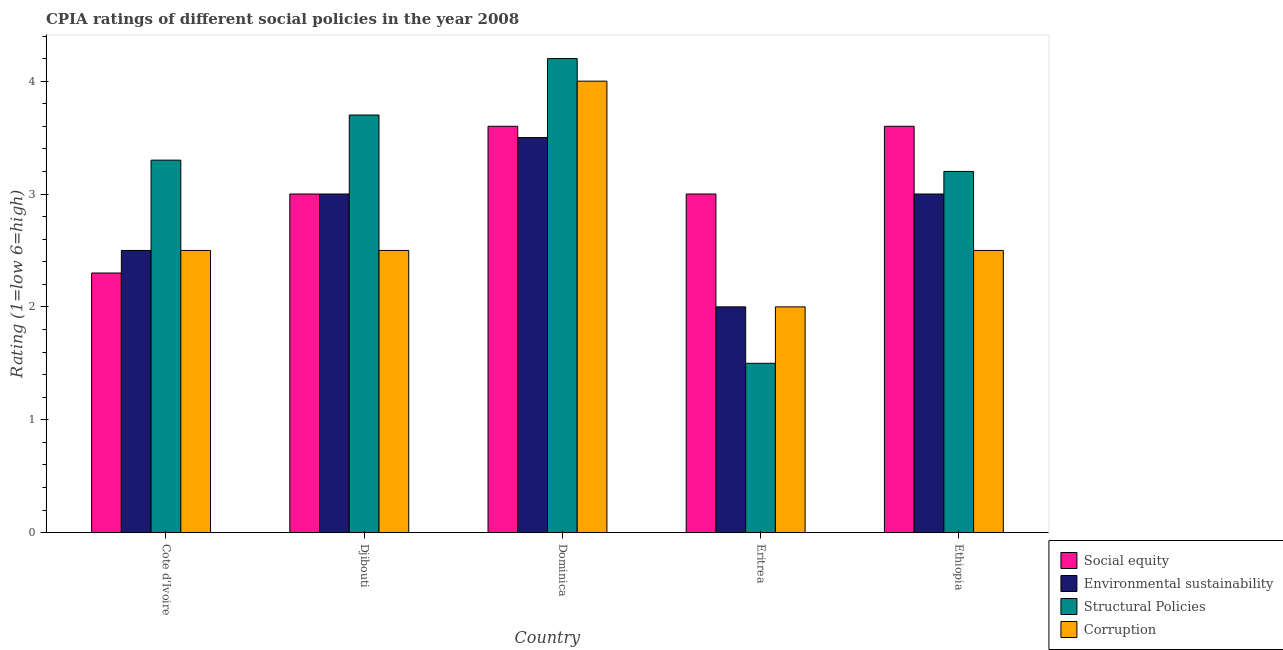How many different coloured bars are there?
Your response must be concise. 4. Are the number of bars on each tick of the X-axis equal?
Your answer should be very brief. Yes. How many bars are there on the 5th tick from the left?
Make the answer very short. 4. What is the label of the 5th group of bars from the left?
Offer a terse response. Ethiopia. Across all countries, what is the maximum cpia rating of corruption?
Your answer should be compact. 4. Across all countries, what is the minimum cpia rating of corruption?
Offer a terse response. 2. In which country was the cpia rating of structural policies maximum?
Provide a succinct answer. Dominica. In which country was the cpia rating of structural policies minimum?
Offer a terse response. Eritrea. What is the total cpia rating of environmental sustainability in the graph?
Make the answer very short. 14. What is the difference between the cpia rating of social equity in Cote d'Ivoire and that in Eritrea?
Give a very brief answer. -0.7. What is the difference between the cpia rating of social equity in Cote d'Ivoire and the cpia rating of structural policies in Eritrea?
Offer a terse response. 0.8. What is the average cpia rating of corruption per country?
Keep it short and to the point. 2.7. What is the difference between the cpia rating of environmental sustainability and cpia rating of structural policies in Djibouti?
Keep it short and to the point. -0.7. What is the ratio of the cpia rating of structural policies in Djibouti to that in Eritrea?
Give a very brief answer. 2.47. Is the cpia rating of environmental sustainability in Cote d'Ivoire less than that in Dominica?
Your answer should be compact. Yes. What is the difference between the highest and the lowest cpia rating of social equity?
Your answer should be very brief. 1.3. What does the 3rd bar from the left in Dominica represents?
Your answer should be compact. Structural Policies. What does the 1st bar from the right in Cote d'Ivoire represents?
Your answer should be very brief. Corruption. Is it the case that in every country, the sum of the cpia rating of social equity and cpia rating of environmental sustainability is greater than the cpia rating of structural policies?
Provide a succinct answer. Yes. What is the difference between two consecutive major ticks on the Y-axis?
Make the answer very short. 1. Does the graph contain any zero values?
Give a very brief answer. No. Does the graph contain grids?
Your response must be concise. No. Where does the legend appear in the graph?
Make the answer very short. Bottom right. How many legend labels are there?
Your response must be concise. 4. How are the legend labels stacked?
Offer a very short reply. Vertical. What is the title of the graph?
Give a very brief answer. CPIA ratings of different social policies in the year 2008. What is the label or title of the X-axis?
Ensure brevity in your answer.  Country. What is the label or title of the Y-axis?
Give a very brief answer. Rating (1=low 6=high). What is the Rating (1=low 6=high) of Structural Policies in Cote d'Ivoire?
Give a very brief answer. 3.3. What is the Rating (1=low 6=high) of Social equity in Djibouti?
Your answer should be very brief. 3. What is the Rating (1=low 6=high) in Environmental sustainability in Djibouti?
Keep it short and to the point. 3. What is the Rating (1=low 6=high) in Environmental sustainability in Dominica?
Provide a short and direct response. 3.5. What is the Rating (1=low 6=high) of Corruption in Dominica?
Make the answer very short. 4. What is the Rating (1=low 6=high) of Social equity in Eritrea?
Provide a succinct answer. 3. What is the Rating (1=low 6=high) of Environmental sustainability in Eritrea?
Provide a short and direct response. 2. What is the Rating (1=low 6=high) of Corruption in Eritrea?
Your response must be concise. 2. What is the Rating (1=low 6=high) in Corruption in Ethiopia?
Ensure brevity in your answer.  2.5. Across all countries, what is the maximum Rating (1=low 6=high) of Social equity?
Your answer should be compact. 3.6. Across all countries, what is the maximum Rating (1=low 6=high) in Environmental sustainability?
Ensure brevity in your answer.  3.5. Across all countries, what is the maximum Rating (1=low 6=high) of Structural Policies?
Provide a succinct answer. 4.2. Across all countries, what is the minimum Rating (1=low 6=high) in Social equity?
Provide a succinct answer. 2.3. Across all countries, what is the minimum Rating (1=low 6=high) in Environmental sustainability?
Offer a very short reply. 2. What is the total Rating (1=low 6=high) in Environmental sustainability in the graph?
Provide a short and direct response. 14. What is the difference between the Rating (1=low 6=high) of Social equity in Cote d'Ivoire and that in Djibouti?
Offer a very short reply. -0.7. What is the difference between the Rating (1=low 6=high) of Corruption in Cote d'Ivoire and that in Djibouti?
Provide a short and direct response. 0. What is the difference between the Rating (1=low 6=high) in Structural Policies in Cote d'Ivoire and that in Dominica?
Keep it short and to the point. -0.9. What is the difference between the Rating (1=low 6=high) of Corruption in Cote d'Ivoire and that in Eritrea?
Your answer should be compact. 0.5. What is the difference between the Rating (1=low 6=high) of Social equity in Cote d'Ivoire and that in Ethiopia?
Offer a terse response. -1.3. What is the difference between the Rating (1=low 6=high) in Structural Policies in Cote d'Ivoire and that in Ethiopia?
Make the answer very short. 0.1. What is the difference between the Rating (1=low 6=high) in Corruption in Cote d'Ivoire and that in Ethiopia?
Provide a succinct answer. 0. What is the difference between the Rating (1=low 6=high) in Environmental sustainability in Djibouti and that in Dominica?
Ensure brevity in your answer.  -0.5. What is the difference between the Rating (1=low 6=high) of Structural Policies in Djibouti and that in Dominica?
Provide a short and direct response. -0.5. What is the difference between the Rating (1=low 6=high) in Corruption in Djibouti and that in Dominica?
Offer a very short reply. -1.5. What is the difference between the Rating (1=low 6=high) in Social equity in Djibouti and that in Ethiopia?
Your answer should be very brief. -0.6. What is the difference between the Rating (1=low 6=high) in Environmental sustainability in Djibouti and that in Ethiopia?
Provide a succinct answer. 0. What is the difference between the Rating (1=low 6=high) of Structural Policies in Djibouti and that in Ethiopia?
Give a very brief answer. 0.5. What is the difference between the Rating (1=low 6=high) in Corruption in Djibouti and that in Ethiopia?
Make the answer very short. 0. What is the difference between the Rating (1=low 6=high) in Environmental sustainability in Dominica and that in Eritrea?
Give a very brief answer. 1.5. What is the difference between the Rating (1=low 6=high) in Structural Policies in Dominica and that in Eritrea?
Offer a terse response. 2.7. What is the difference between the Rating (1=low 6=high) in Corruption in Dominica and that in Eritrea?
Provide a succinct answer. 2. What is the difference between the Rating (1=low 6=high) of Environmental sustainability in Dominica and that in Ethiopia?
Give a very brief answer. 0.5. What is the difference between the Rating (1=low 6=high) of Structural Policies in Dominica and that in Ethiopia?
Give a very brief answer. 1. What is the difference between the Rating (1=low 6=high) in Social equity in Eritrea and that in Ethiopia?
Make the answer very short. -0.6. What is the difference between the Rating (1=low 6=high) of Environmental sustainability in Eritrea and that in Ethiopia?
Ensure brevity in your answer.  -1. What is the difference between the Rating (1=low 6=high) of Structural Policies in Cote d'Ivoire and the Rating (1=low 6=high) of Corruption in Djibouti?
Provide a succinct answer. 0.8. What is the difference between the Rating (1=low 6=high) of Environmental sustainability in Cote d'Ivoire and the Rating (1=low 6=high) of Structural Policies in Dominica?
Offer a terse response. -1.7. What is the difference between the Rating (1=low 6=high) of Environmental sustainability in Cote d'Ivoire and the Rating (1=low 6=high) of Corruption in Dominica?
Your answer should be very brief. -1.5. What is the difference between the Rating (1=low 6=high) of Structural Policies in Cote d'Ivoire and the Rating (1=low 6=high) of Corruption in Dominica?
Provide a succinct answer. -0.7. What is the difference between the Rating (1=low 6=high) in Social equity in Cote d'Ivoire and the Rating (1=low 6=high) in Environmental sustainability in Eritrea?
Your answer should be compact. 0.3. What is the difference between the Rating (1=low 6=high) in Social equity in Cote d'Ivoire and the Rating (1=low 6=high) in Structural Policies in Eritrea?
Offer a terse response. 0.8. What is the difference between the Rating (1=low 6=high) in Social equity in Cote d'Ivoire and the Rating (1=low 6=high) in Corruption in Eritrea?
Offer a very short reply. 0.3. What is the difference between the Rating (1=low 6=high) of Environmental sustainability in Cote d'Ivoire and the Rating (1=low 6=high) of Corruption in Eritrea?
Your answer should be very brief. 0.5. What is the difference between the Rating (1=low 6=high) in Social equity in Cote d'Ivoire and the Rating (1=low 6=high) in Environmental sustainability in Ethiopia?
Your answer should be compact. -0.7. What is the difference between the Rating (1=low 6=high) in Social equity in Cote d'Ivoire and the Rating (1=low 6=high) in Corruption in Ethiopia?
Provide a short and direct response. -0.2. What is the difference between the Rating (1=low 6=high) in Environmental sustainability in Cote d'Ivoire and the Rating (1=low 6=high) in Corruption in Ethiopia?
Offer a terse response. 0. What is the difference between the Rating (1=low 6=high) in Structural Policies in Cote d'Ivoire and the Rating (1=low 6=high) in Corruption in Ethiopia?
Offer a terse response. 0.8. What is the difference between the Rating (1=low 6=high) of Social equity in Djibouti and the Rating (1=low 6=high) of Environmental sustainability in Dominica?
Your answer should be compact. -0.5. What is the difference between the Rating (1=low 6=high) of Social equity in Djibouti and the Rating (1=low 6=high) of Structural Policies in Dominica?
Provide a succinct answer. -1.2. What is the difference between the Rating (1=low 6=high) in Environmental sustainability in Djibouti and the Rating (1=low 6=high) in Corruption in Dominica?
Make the answer very short. -1. What is the difference between the Rating (1=low 6=high) in Environmental sustainability in Djibouti and the Rating (1=low 6=high) in Corruption in Eritrea?
Your answer should be very brief. 1. What is the difference between the Rating (1=low 6=high) in Structural Policies in Djibouti and the Rating (1=low 6=high) in Corruption in Eritrea?
Keep it short and to the point. 1.7. What is the difference between the Rating (1=low 6=high) in Structural Policies in Djibouti and the Rating (1=low 6=high) in Corruption in Ethiopia?
Ensure brevity in your answer.  1.2. What is the difference between the Rating (1=low 6=high) in Social equity in Dominica and the Rating (1=low 6=high) in Environmental sustainability in Eritrea?
Keep it short and to the point. 1.6. What is the difference between the Rating (1=low 6=high) in Social equity in Dominica and the Rating (1=low 6=high) in Structural Policies in Eritrea?
Give a very brief answer. 2.1. What is the difference between the Rating (1=low 6=high) of Social equity in Dominica and the Rating (1=low 6=high) of Corruption in Eritrea?
Offer a very short reply. 1.6. What is the difference between the Rating (1=low 6=high) in Environmental sustainability in Dominica and the Rating (1=low 6=high) in Structural Policies in Eritrea?
Your response must be concise. 2. What is the difference between the Rating (1=low 6=high) of Social equity in Dominica and the Rating (1=low 6=high) of Environmental sustainability in Ethiopia?
Your answer should be compact. 0.6. What is the difference between the Rating (1=low 6=high) of Social equity in Dominica and the Rating (1=low 6=high) of Structural Policies in Ethiopia?
Your response must be concise. 0.4. What is the difference between the Rating (1=low 6=high) in Environmental sustainability in Dominica and the Rating (1=low 6=high) in Structural Policies in Ethiopia?
Give a very brief answer. 0.3. What is the difference between the Rating (1=low 6=high) in Environmental sustainability in Dominica and the Rating (1=low 6=high) in Corruption in Ethiopia?
Keep it short and to the point. 1. What is the difference between the Rating (1=low 6=high) in Social equity in Eritrea and the Rating (1=low 6=high) in Structural Policies in Ethiopia?
Offer a terse response. -0.2. What is the difference between the Rating (1=low 6=high) of Environmental sustainability in Eritrea and the Rating (1=low 6=high) of Corruption in Ethiopia?
Offer a terse response. -0.5. What is the average Rating (1=low 6=high) of Social equity per country?
Offer a terse response. 3.1. What is the average Rating (1=low 6=high) of Environmental sustainability per country?
Keep it short and to the point. 2.8. What is the average Rating (1=low 6=high) of Structural Policies per country?
Keep it short and to the point. 3.18. What is the average Rating (1=low 6=high) in Corruption per country?
Offer a very short reply. 2.7. What is the difference between the Rating (1=low 6=high) in Social equity and Rating (1=low 6=high) in Structural Policies in Cote d'Ivoire?
Ensure brevity in your answer.  -1. What is the difference between the Rating (1=low 6=high) in Social equity and Rating (1=low 6=high) in Corruption in Cote d'Ivoire?
Make the answer very short. -0.2. What is the difference between the Rating (1=low 6=high) in Environmental sustainability and Rating (1=low 6=high) in Structural Policies in Cote d'Ivoire?
Ensure brevity in your answer.  -0.8. What is the difference between the Rating (1=low 6=high) in Environmental sustainability and Rating (1=low 6=high) in Corruption in Cote d'Ivoire?
Your response must be concise. 0. What is the difference between the Rating (1=low 6=high) in Structural Policies and Rating (1=low 6=high) in Corruption in Cote d'Ivoire?
Provide a succinct answer. 0.8. What is the difference between the Rating (1=low 6=high) in Social equity and Rating (1=low 6=high) in Environmental sustainability in Djibouti?
Provide a succinct answer. 0. What is the difference between the Rating (1=low 6=high) of Social equity and Rating (1=low 6=high) of Corruption in Djibouti?
Provide a short and direct response. 0.5. What is the difference between the Rating (1=low 6=high) in Structural Policies and Rating (1=low 6=high) in Corruption in Djibouti?
Keep it short and to the point. 1.2. What is the difference between the Rating (1=low 6=high) of Social equity and Rating (1=low 6=high) of Environmental sustainability in Dominica?
Provide a short and direct response. 0.1. What is the difference between the Rating (1=low 6=high) in Social equity and Rating (1=low 6=high) in Structural Policies in Dominica?
Offer a very short reply. -0.6. What is the difference between the Rating (1=low 6=high) in Environmental sustainability and Rating (1=low 6=high) in Structural Policies in Dominica?
Your answer should be compact. -0.7. What is the difference between the Rating (1=low 6=high) of Social equity and Rating (1=low 6=high) of Corruption in Eritrea?
Make the answer very short. 1. What is the difference between the Rating (1=low 6=high) of Environmental sustainability and Rating (1=low 6=high) of Structural Policies in Eritrea?
Your response must be concise. 0.5. What is the difference between the Rating (1=low 6=high) of Structural Policies and Rating (1=low 6=high) of Corruption in Eritrea?
Provide a short and direct response. -0.5. What is the difference between the Rating (1=low 6=high) in Environmental sustainability and Rating (1=low 6=high) in Structural Policies in Ethiopia?
Provide a short and direct response. -0.2. What is the difference between the Rating (1=low 6=high) of Environmental sustainability and Rating (1=low 6=high) of Corruption in Ethiopia?
Your response must be concise. 0.5. What is the difference between the Rating (1=low 6=high) of Structural Policies and Rating (1=low 6=high) of Corruption in Ethiopia?
Provide a succinct answer. 0.7. What is the ratio of the Rating (1=low 6=high) of Social equity in Cote d'Ivoire to that in Djibouti?
Provide a succinct answer. 0.77. What is the ratio of the Rating (1=low 6=high) in Structural Policies in Cote d'Ivoire to that in Djibouti?
Make the answer very short. 0.89. What is the ratio of the Rating (1=low 6=high) of Corruption in Cote d'Ivoire to that in Djibouti?
Provide a short and direct response. 1. What is the ratio of the Rating (1=low 6=high) in Social equity in Cote d'Ivoire to that in Dominica?
Keep it short and to the point. 0.64. What is the ratio of the Rating (1=low 6=high) in Structural Policies in Cote d'Ivoire to that in Dominica?
Provide a short and direct response. 0.79. What is the ratio of the Rating (1=low 6=high) in Social equity in Cote d'Ivoire to that in Eritrea?
Your answer should be very brief. 0.77. What is the ratio of the Rating (1=low 6=high) in Corruption in Cote d'Ivoire to that in Eritrea?
Offer a terse response. 1.25. What is the ratio of the Rating (1=low 6=high) of Social equity in Cote d'Ivoire to that in Ethiopia?
Your answer should be compact. 0.64. What is the ratio of the Rating (1=low 6=high) in Structural Policies in Cote d'Ivoire to that in Ethiopia?
Give a very brief answer. 1.03. What is the ratio of the Rating (1=low 6=high) in Corruption in Cote d'Ivoire to that in Ethiopia?
Make the answer very short. 1. What is the ratio of the Rating (1=low 6=high) of Social equity in Djibouti to that in Dominica?
Provide a short and direct response. 0.83. What is the ratio of the Rating (1=low 6=high) of Environmental sustainability in Djibouti to that in Dominica?
Your answer should be compact. 0.86. What is the ratio of the Rating (1=low 6=high) of Structural Policies in Djibouti to that in Dominica?
Make the answer very short. 0.88. What is the ratio of the Rating (1=low 6=high) in Structural Policies in Djibouti to that in Eritrea?
Provide a succinct answer. 2.47. What is the ratio of the Rating (1=low 6=high) of Corruption in Djibouti to that in Eritrea?
Provide a short and direct response. 1.25. What is the ratio of the Rating (1=low 6=high) of Structural Policies in Djibouti to that in Ethiopia?
Your response must be concise. 1.16. What is the ratio of the Rating (1=low 6=high) of Corruption in Djibouti to that in Ethiopia?
Your answer should be very brief. 1. What is the ratio of the Rating (1=low 6=high) of Environmental sustainability in Dominica to that in Eritrea?
Give a very brief answer. 1.75. What is the ratio of the Rating (1=low 6=high) in Corruption in Dominica to that in Eritrea?
Your answer should be compact. 2. What is the ratio of the Rating (1=low 6=high) in Social equity in Dominica to that in Ethiopia?
Provide a succinct answer. 1. What is the ratio of the Rating (1=low 6=high) of Environmental sustainability in Dominica to that in Ethiopia?
Your response must be concise. 1.17. What is the ratio of the Rating (1=low 6=high) of Structural Policies in Dominica to that in Ethiopia?
Give a very brief answer. 1.31. What is the ratio of the Rating (1=low 6=high) in Corruption in Dominica to that in Ethiopia?
Offer a terse response. 1.6. What is the ratio of the Rating (1=low 6=high) in Social equity in Eritrea to that in Ethiopia?
Your response must be concise. 0.83. What is the ratio of the Rating (1=low 6=high) in Structural Policies in Eritrea to that in Ethiopia?
Your response must be concise. 0.47. What is the difference between the highest and the second highest Rating (1=low 6=high) in Environmental sustainability?
Offer a very short reply. 0.5. What is the difference between the highest and the second highest Rating (1=low 6=high) in Structural Policies?
Your answer should be compact. 0.5. What is the difference between the highest and the second highest Rating (1=low 6=high) in Corruption?
Provide a short and direct response. 1.5. What is the difference between the highest and the lowest Rating (1=low 6=high) in Environmental sustainability?
Ensure brevity in your answer.  1.5. What is the difference between the highest and the lowest Rating (1=low 6=high) of Corruption?
Your response must be concise. 2. 